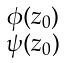<formula> <loc_0><loc_0><loc_500><loc_500>\begin{smallmatrix} \phi ( z _ { 0 } ) \\ \psi ( z _ { 0 } ) \\ \end{smallmatrix}</formula> 